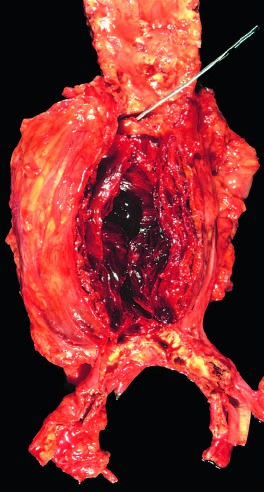s acute cellular rejection of a kidney graft attenuated?
Answer the question using a single word or phrase. No 